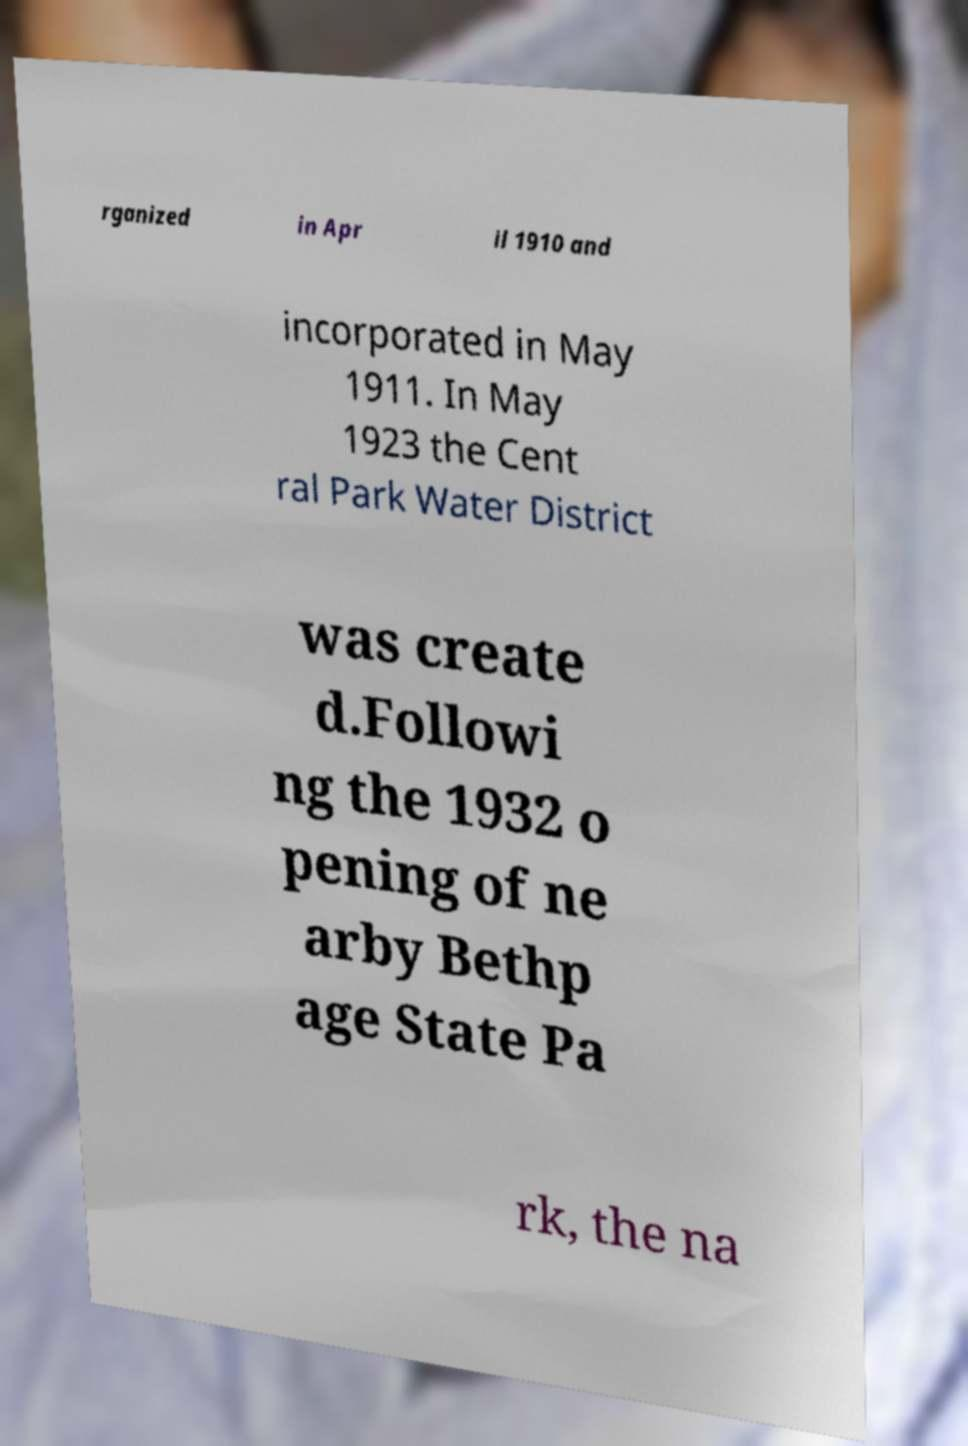Can you accurately transcribe the text from the provided image for me? rganized in Apr il 1910 and incorporated in May 1911. In May 1923 the Cent ral Park Water District was create d.Followi ng the 1932 o pening of ne arby Bethp age State Pa rk, the na 